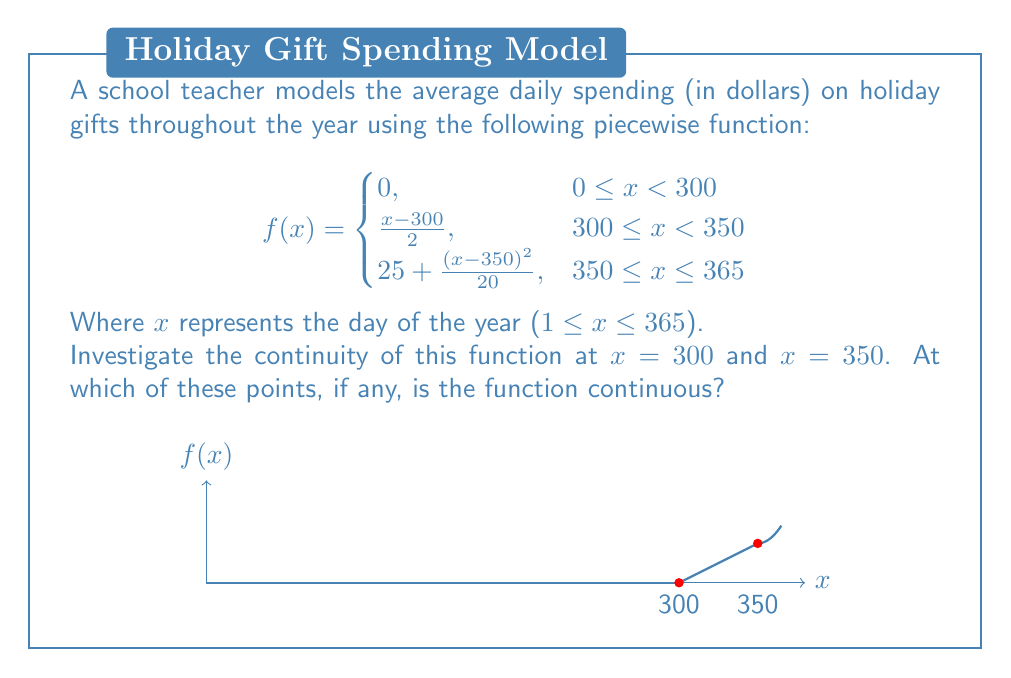Help me with this question. To investigate the continuity of the function at $x = 300$ and $x = 350$, we need to check three conditions for each point:
1. The function is defined at the point.
2. The limit of the function exists as we approach the point from both sides.
3. The limit equals the function value at that point.

For $x = 300$:

1. $f(300)$ is defined: $f(300) = 0$ (using the second piece of the function)
2. Left-hand limit: $\lim_{x \to 300^-} f(x) = 0$
   Right-hand limit: $\lim_{x \to 300^+} f(x) = \lim_{x \to 300^+} \frac{x-300}{2} = 0$
3. $\lim_{x \to 300} f(x) = f(300) = 0$

All three conditions are satisfied, so the function is continuous at $x = 300$.

For $x = 350$:

1. $f(350)$ is defined: $f(350) = 25$ (using either the second or third piece)
2. Left-hand limit: $\lim_{x \to 350^-} f(x) = \lim_{x \to 350^-} \frac{x-300}{2} = 25$
   Right-hand limit: $\lim_{x \to 350^+} f(x) = \lim_{x \to 350^+} (25 + \frac{(x-350)^2}{20}) = 25$
3. $\lim_{x \to 350} f(x) = f(350) = 25$

All three conditions are satisfied, so the function is continuous at $x = 350$.
Answer: The function is continuous at both $x = 300$ and $x = 350$. 